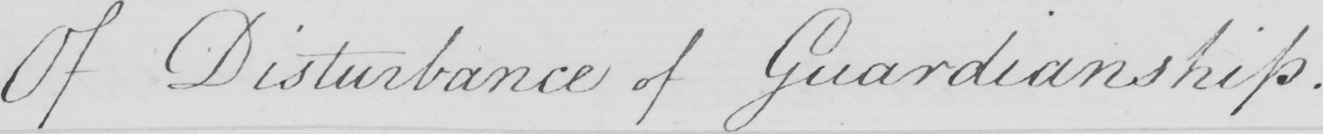Can you tell me what this handwritten text says? Of Disturbance of Guardianship . 